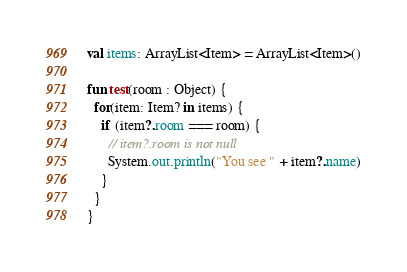<code> <loc_0><loc_0><loc_500><loc_500><_Kotlin_>
val items: ArrayList<Item> = ArrayList<Item>()

fun test(room : Object) {
  for(item: Item? in items) {
    if (item?.room === room) {
      // item?.room is not null
      System.out.println("You see " + item?.name)
    }
  }
}</code> 